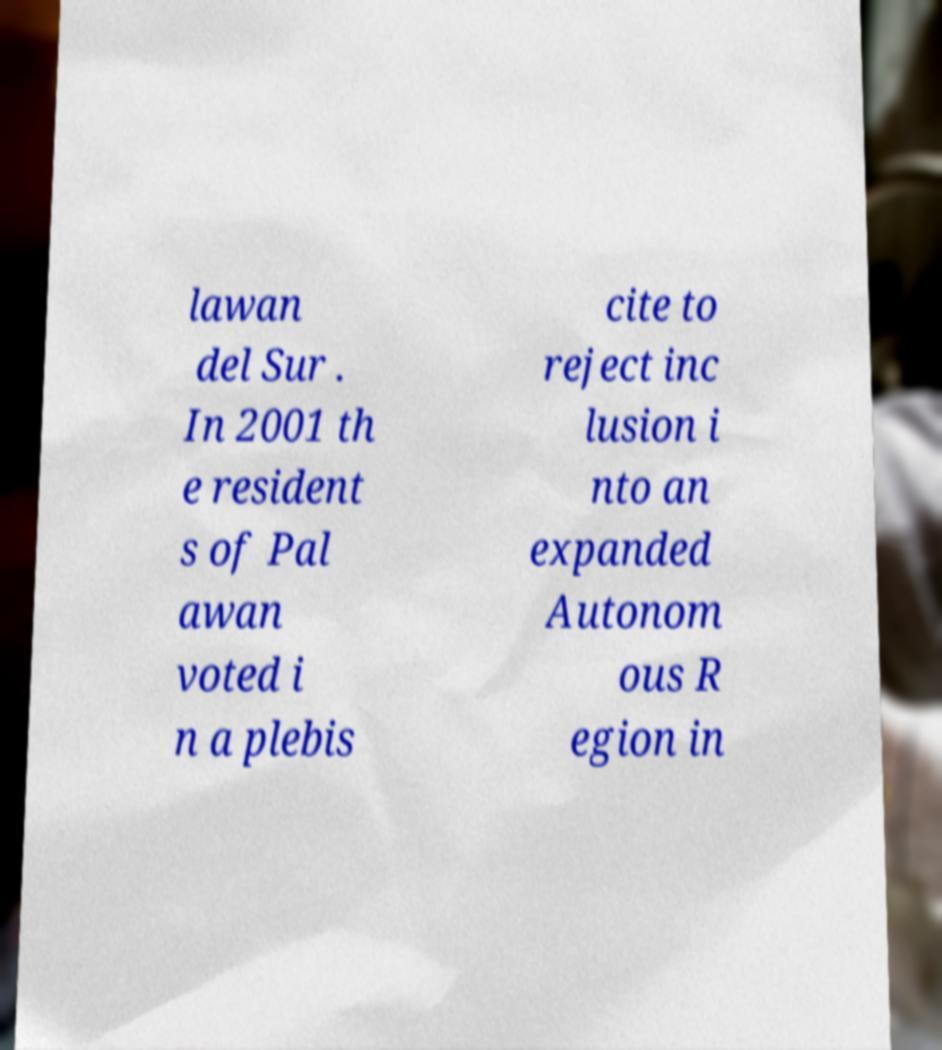I need the written content from this picture converted into text. Can you do that? lawan del Sur . In 2001 th e resident s of Pal awan voted i n a plebis cite to reject inc lusion i nto an expanded Autonom ous R egion in 